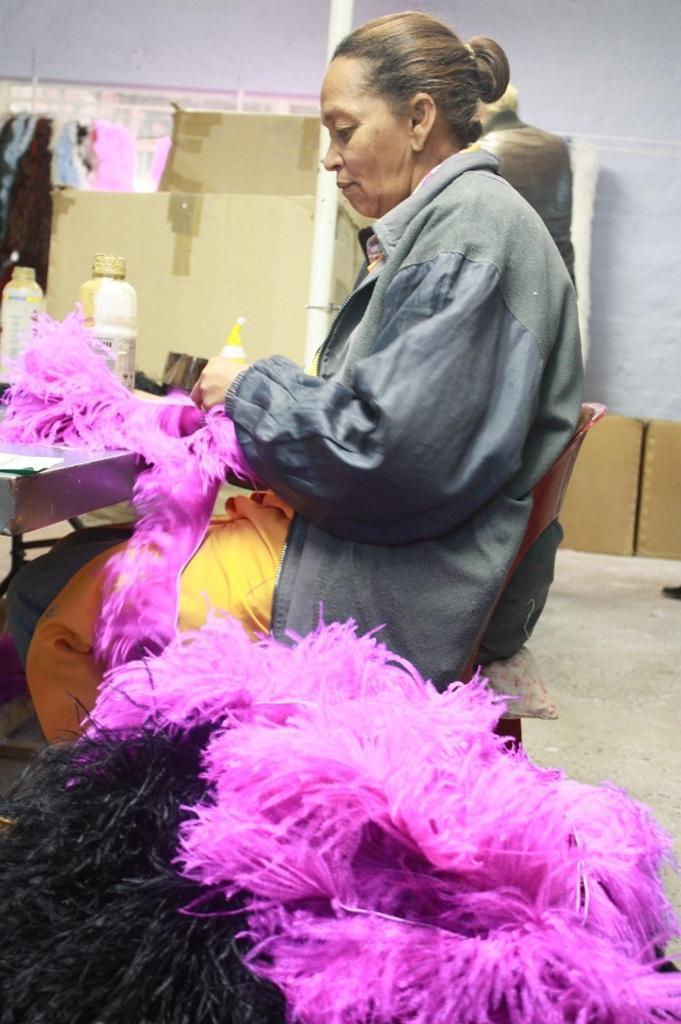Could you give a brief overview of what you see in this image? There is a woman sitting on the chair. Here we can see a table. On the table there are bottles and objects. In the background we can see wall, boxes, and a person. 